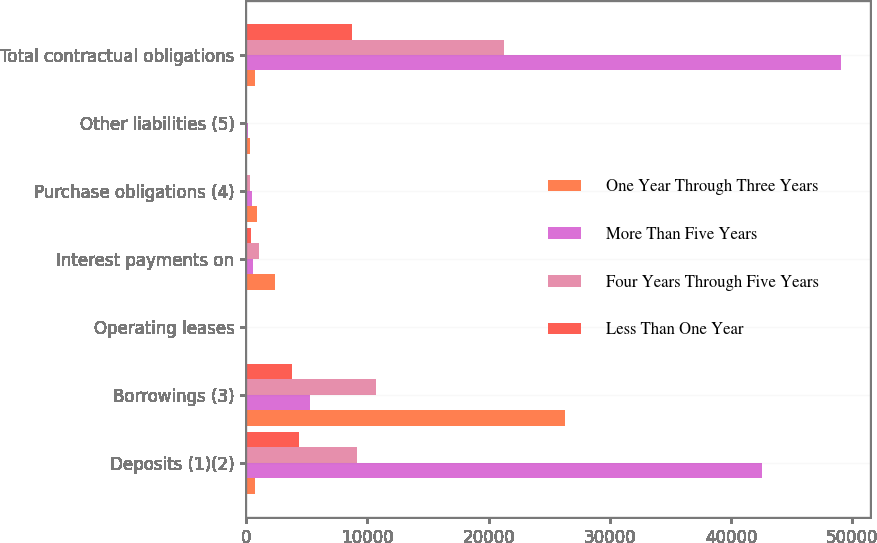Convert chart. <chart><loc_0><loc_0><loc_500><loc_500><stacked_bar_chart><ecel><fcel>Deposits (1)(2)<fcel>Borrowings (3)<fcel>Operating leases<fcel>Interest payments on<fcel>Purchase obligations (4)<fcel>Other liabilities (5)<fcel>Total contractual obligations<nl><fcel>One Year Through Three Years<fcel>712.5<fcel>26326<fcel>94<fcel>2404<fcel>885<fcel>348<fcel>712.5<nl><fcel>More Than Five Years<fcel>42562<fcel>5272<fcel>13<fcel>540<fcel>507<fcel>147<fcel>49041<nl><fcel>Four Years Through Five Years<fcel>9128<fcel>10704<fcel>23<fcel>1046<fcel>349<fcel>48<fcel>21298<nl><fcel>Less Than One Year<fcel>4368<fcel>3815<fcel>17<fcel>431<fcel>27<fcel>36<fcel>8694<nl></chart> 